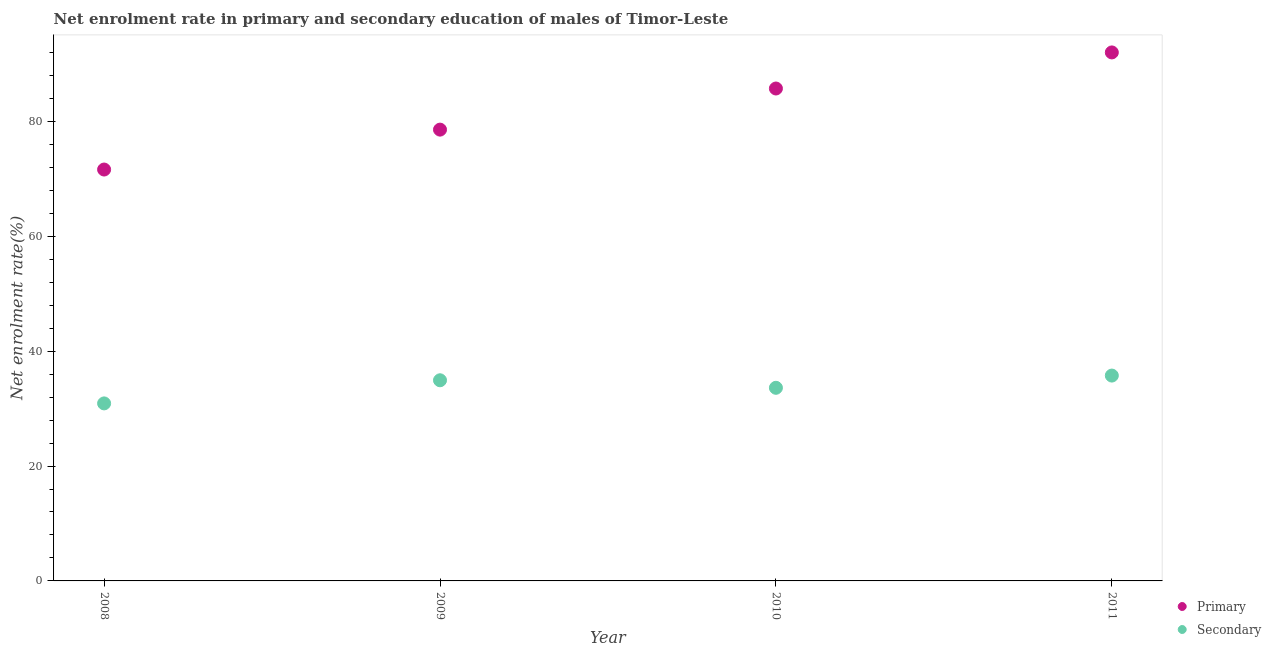How many different coloured dotlines are there?
Your answer should be very brief. 2. Is the number of dotlines equal to the number of legend labels?
Make the answer very short. Yes. What is the enrollment rate in primary education in 2009?
Make the answer very short. 78.57. Across all years, what is the maximum enrollment rate in secondary education?
Ensure brevity in your answer.  35.75. Across all years, what is the minimum enrollment rate in primary education?
Offer a very short reply. 71.63. In which year was the enrollment rate in primary education maximum?
Your answer should be very brief. 2011. What is the total enrollment rate in primary education in the graph?
Provide a short and direct response. 327.95. What is the difference between the enrollment rate in primary education in 2009 and that in 2010?
Keep it short and to the point. -7.16. What is the difference between the enrollment rate in secondary education in 2010 and the enrollment rate in primary education in 2008?
Provide a succinct answer. -38. What is the average enrollment rate in secondary education per year?
Make the answer very short. 33.8. In the year 2008, what is the difference between the enrollment rate in primary education and enrollment rate in secondary education?
Make the answer very short. 40.72. In how many years, is the enrollment rate in primary education greater than 44 %?
Keep it short and to the point. 4. What is the ratio of the enrollment rate in primary education in 2010 to that in 2011?
Offer a terse response. 0.93. Is the enrollment rate in primary education in 2009 less than that in 2011?
Offer a very short reply. Yes. Is the difference between the enrollment rate in primary education in 2010 and 2011 greater than the difference between the enrollment rate in secondary education in 2010 and 2011?
Your response must be concise. No. What is the difference between the highest and the second highest enrollment rate in secondary education?
Your response must be concise. 0.82. What is the difference between the highest and the lowest enrollment rate in secondary education?
Provide a short and direct response. 4.84. In how many years, is the enrollment rate in primary education greater than the average enrollment rate in primary education taken over all years?
Make the answer very short. 2. Is the sum of the enrollment rate in primary education in 2008 and 2009 greater than the maximum enrollment rate in secondary education across all years?
Ensure brevity in your answer.  Yes. Is the enrollment rate in primary education strictly greater than the enrollment rate in secondary education over the years?
Give a very brief answer. Yes. Are the values on the major ticks of Y-axis written in scientific E-notation?
Offer a terse response. No. Where does the legend appear in the graph?
Your response must be concise. Bottom right. How many legend labels are there?
Your answer should be very brief. 2. What is the title of the graph?
Offer a very short reply. Net enrolment rate in primary and secondary education of males of Timor-Leste. What is the label or title of the X-axis?
Offer a terse response. Year. What is the label or title of the Y-axis?
Keep it short and to the point. Net enrolment rate(%). What is the Net enrolment rate(%) of Primary in 2008?
Provide a succinct answer. 71.63. What is the Net enrolment rate(%) in Secondary in 2008?
Ensure brevity in your answer.  30.91. What is the Net enrolment rate(%) in Primary in 2009?
Ensure brevity in your answer.  78.57. What is the Net enrolment rate(%) of Secondary in 2009?
Keep it short and to the point. 34.93. What is the Net enrolment rate(%) in Primary in 2010?
Provide a short and direct response. 85.73. What is the Net enrolment rate(%) of Secondary in 2010?
Offer a terse response. 33.62. What is the Net enrolment rate(%) in Primary in 2011?
Provide a short and direct response. 92.02. What is the Net enrolment rate(%) in Secondary in 2011?
Provide a succinct answer. 35.75. Across all years, what is the maximum Net enrolment rate(%) in Primary?
Offer a terse response. 92.02. Across all years, what is the maximum Net enrolment rate(%) in Secondary?
Ensure brevity in your answer.  35.75. Across all years, what is the minimum Net enrolment rate(%) in Primary?
Provide a short and direct response. 71.63. Across all years, what is the minimum Net enrolment rate(%) in Secondary?
Ensure brevity in your answer.  30.91. What is the total Net enrolment rate(%) of Primary in the graph?
Provide a short and direct response. 327.95. What is the total Net enrolment rate(%) in Secondary in the graph?
Provide a short and direct response. 135.22. What is the difference between the Net enrolment rate(%) of Primary in 2008 and that in 2009?
Keep it short and to the point. -6.95. What is the difference between the Net enrolment rate(%) of Secondary in 2008 and that in 2009?
Ensure brevity in your answer.  -4.03. What is the difference between the Net enrolment rate(%) in Primary in 2008 and that in 2010?
Your response must be concise. -14.11. What is the difference between the Net enrolment rate(%) of Secondary in 2008 and that in 2010?
Your answer should be very brief. -2.72. What is the difference between the Net enrolment rate(%) of Primary in 2008 and that in 2011?
Ensure brevity in your answer.  -20.39. What is the difference between the Net enrolment rate(%) of Secondary in 2008 and that in 2011?
Offer a very short reply. -4.84. What is the difference between the Net enrolment rate(%) of Primary in 2009 and that in 2010?
Offer a very short reply. -7.16. What is the difference between the Net enrolment rate(%) in Secondary in 2009 and that in 2010?
Offer a very short reply. 1.31. What is the difference between the Net enrolment rate(%) in Primary in 2009 and that in 2011?
Your response must be concise. -13.44. What is the difference between the Net enrolment rate(%) in Secondary in 2009 and that in 2011?
Make the answer very short. -0.82. What is the difference between the Net enrolment rate(%) of Primary in 2010 and that in 2011?
Offer a very short reply. -6.28. What is the difference between the Net enrolment rate(%) of Secondary in 2010 and that in 2011?
Provide a short and direct response. -2.13. What is the difference between the Net enrolment rate(%) in Primary in 2008 and the Net enrolment rate(%) in Secondary in 2009?
Your answer should be very brief. 36.69. What is the difference between the Net enrolment rate(%) of Primary in 2008 and the Net enrolment rate(%) of Secondary in 2010?
Your answer should be very brief. 38. What is the difference between the Net enrolment rate(%) of Primary in 2008 and the Net enrolment rate(%) of Secondary in 2011?
Ensure brevity in your answer.  35.87. What is the difference between the Net enrolment rate(%) of Primary in 2009 and the Net enrolment rate(%) of Secondary in 2010?
Ensure brevity in your answer.  44.95. What is the difference between the Net enrolment rate(%) in Primary in 2009 and the Net enrolment rate(%) in Secondary in 2011?
Your answer should be very brief. 42.82. What is the difference between the Net enrolment rate(%) in Primary in 2010 and the Net enrolment rate(%) in Secondary in 2011?
Provide a succinct answer. 49.98. What is the average Net enrolment rate(%) of Primary per year?
Give a very brief answer. 81.99. What is the average Net enrolment rate(%) in Secondary per year?
Your answer should be very brief. 33.8. In the year 2008, what is the difference between the Net enrolment rate(%) of Primary and Net enrolment rate(%) of Secondary?
Your response must be concise. 40.72. In the year 2009, what is the difference between the Net enrolment rate(%) in Primary and Net enrolment rate(%) in Secondary?
Keep it short and to the point. 43.64. In the year 2010, what is the difference between the Net enrolment rate(%) of Primary and Net enrolment rate(%) of Secondary?
Provide a succinct answer. 52.11. In the year 2011, what is the difference between the Net enrolment rate(%) in Primary and Net enrolment rate(%) in Secondary?
Keep it short and to the point. 56.26. What is the ratio of the Net enrolment rate(%) of Primary in 2008 to that in 2009?
Your answer should be very brief. 0.91. What is the ratio of the Net enrolment rate(%) in Secondary in 2008 to that in 2009?
Your answer should be compact. 0.88. What is the ratio of the Net enrolment rate(%) of Primary in 2008 to that in 2010?
Keep it short and to the point. 0.84. What is the ratio of the Net enrolment rate(%) in Secondary in 2008 to that in 2010?
Provide a short and direct response. 0.92. What is the ratio of the Net enrolment rate(%) of Primary in 2008 to that in 2011?
Your response must be concise. 0.78. What is the ratio of the Net enrolment rate(%) in Secondary in 2008 to that in 2011?
Your answer should be very brief. 0.86. What is the ratio of the Net enrolment rate(%) in Primary in 2009 to that in 2010?
Provide a short and direct response. 0.92. What is the ratio of the Net enrolment rate(%) of Secondary in 2009 to that in 2010?
Make the answer very short. 1.04. What is the ratio of the Net enrolment rate(%) of Primary in 2009 to that in 2011?
Keep it short and to the point. 0.85. What is the ratio of the Net enrolment rate(%) of Secondary in 2009 to that in 2011?
Offer a very short reply. 0.98. What is the ratio of the Net enrolment rate(%) of Primary in 2010 to that in 2011?
Your response must be concise. 0.93. What is the ratio of the Net enrolment rate(%) in Secondary in 2010 to that in 2011?
Offer a very short reply. 0.94. What is the difference between the highest and the second highest Net enrolment rate(%) of Primary?
Your answer should be compact. 6.28. What is the difference between the highest and the second highest Net enrolment rate(%) in Secondary?
Your answer should be very brief. 0.82. What is the difference between the highest and the lowest Net enrolment rate(%) in Primary?
Give a very brief answer. 20.39. What is the difference between the highest and the lowest Net enrolment rate(%) in Secondary?
Make the answer very short. 4.84. 